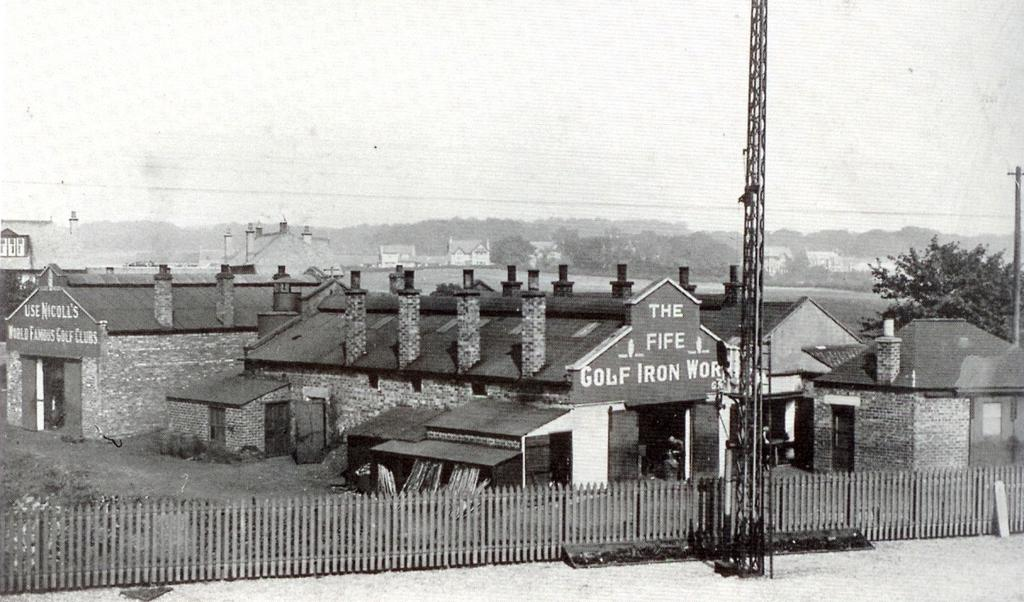What type of structures can be seen in the image? There are sheds in the image. What else can be seen in the image besides the sheds? There are poles, trees, and a fence in the image. What type of furniture can be seen in the image? There is no furniture present in the image; it features sheds, poles, trees, and a fence. How many legs does the basket have in the image? There is no basket present in the image, so it is not possible to determine the number of legs it might have. 